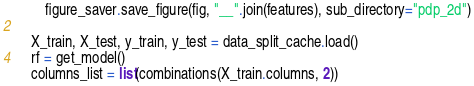Convert code to text. <code><loc_0><loc_0><loc_500><loc_500><_Python_>        figure_saver.save_figure(fig, "__".join(features), sub_directory="pdp_2d")

    X_train, X_test, y_train, y_test = data_split_cache.load()
    rf = get_model()
    columns_list = list(combinations(X_train.columns, 2))
</code> 